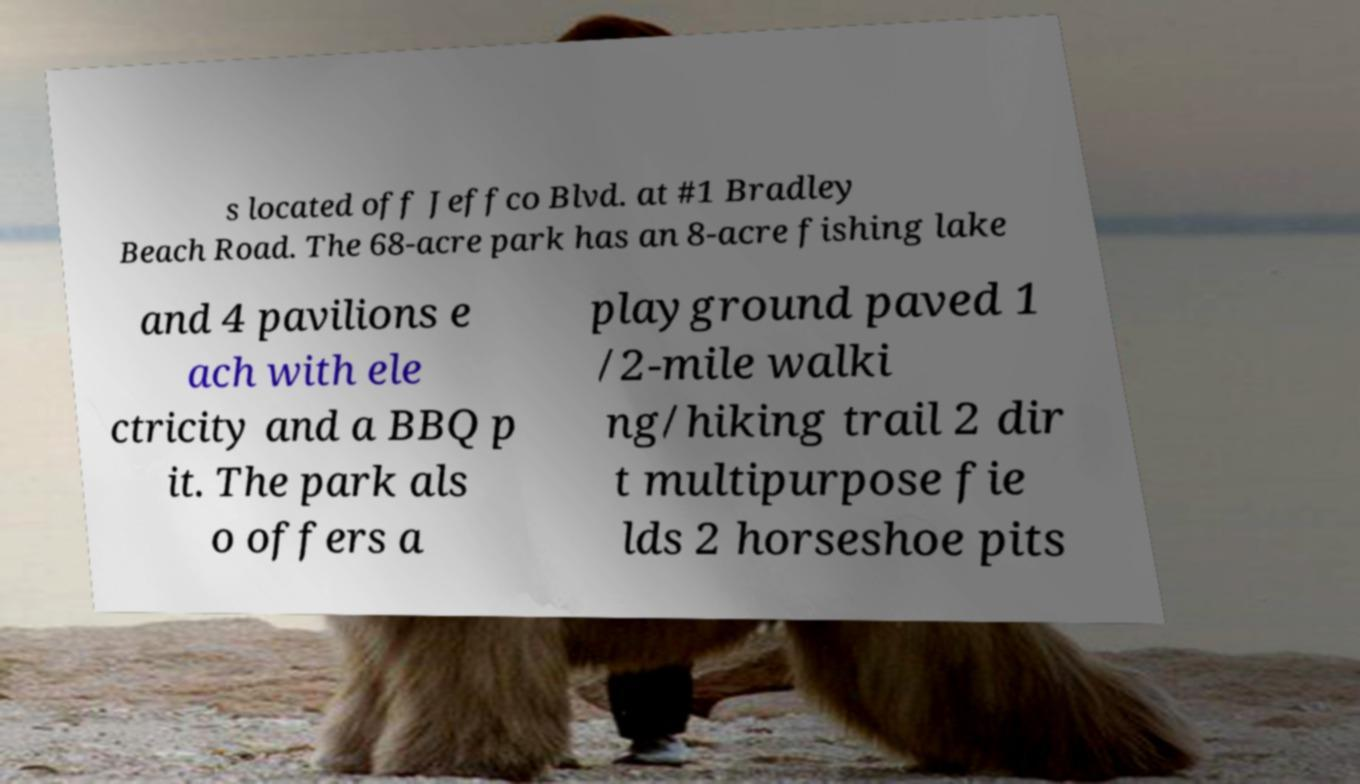There's text embedded in this image that I need extracted. Can you transcribe it verbatim? s located off Jeffco Blvd. at #1 Bradley Beach Road. The 68-acre park has an 8-acre fishing lake and 4 pavilions e ach with ele ctricity and a BBQ p it. The park als o offers a playground paved 1 /2-mile walki ng/hiking trail 2 dir t multipurpose fie lds 2 horseshoe pits 